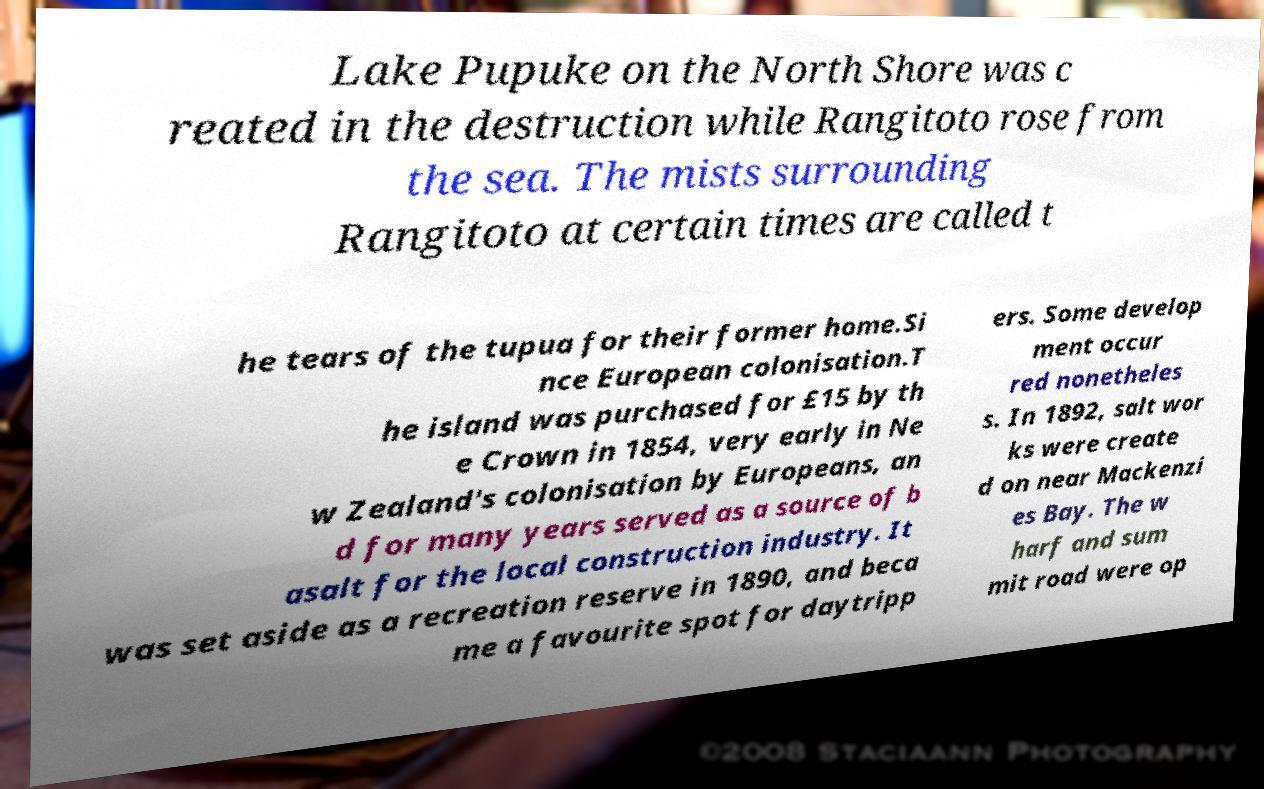Could you extract and type out the text from this image? Lake Pupuke on the North Shore was c reated in the destruction while Rangitoto rose from the sea. The mists surrounding Rangitoto at certain times are called t he tears of the tupua for their former home.Si nce European colonisation.T he island was purchased for £15 by th e Crown in 1854, very early in Ne w Zealand's colonisation by Europeans, an d for many years served as a source of b asalt for the local construction industry. It was set aside as a recreation reserve in 1890, and beca me a favourite spot for daytripp ers. Some develop ment occur red nonetheles s. In 1892, salt wor ks were create d on near Mackenzi es Bay. The w harf and sum mit road were op 